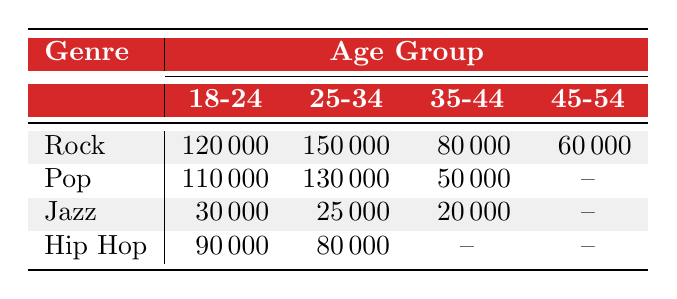What is the attendance for Rock music concerts among the 25-34 age group? The table shows the attendance for different genres among various age groups. For Rock concerts, the attendance for the 25-34 age group is listed as 150000.
Answer: 150000 Which genre has the lowest attendance for the 35-44 age group? By examining the attendances in the 35-44 age group for each genre: Rock has 80000, Pop has 50000, Jazz has 20000, and Hip Hop is not listed (represented by {--}). The lowest attendance is for Jazz with 20000.
Answer: Jazz What is the total attendance for Rock and Pop concerts combined for the 18-24 age group? The attendance for Rock in the 18-24 age group is 120000 and for Pop, it is 110000. Adding these together, 120000 + 110000 equals 230000.
Answer: 230000 Is there any age group for Jazz music concerts that has attendance? Looking at the Jazz attendance, the age groups 18-24, 25-34, and 35-44 have values of 30000, 25000, and 20000 respectively, while 45-54 is not listed (represented by {--}). This means that Jazz has attendance in age groups 18-24, 25-34, and 35-44.
Answer: Yes What is the average attendance for Hip Hop concerts across all age groups reported? In the table for Hip Hop: 18-24 has 90000, 25-34 has 80000, and the other age groups (35-44 and 45-54) show no attendance (represented by {--}). To calculate the average, we will consider only the available attendances: (90000 + 80000) / 2 = 85000. Therefore, the average is calculated based on the two data points we have.
Answer: 85000 Which age group for Pop has the highest attendance? For Pop music, the attendances for age groups are 18-24 with 110000 and 25-34 with 130000. Comparing these values, the highest attendance occurs in the 25-34 age group with 130000.
Answer: 25-34 What is the difference in attendance between the 18-24 age group for Rock and Hip Hop? The attendance for Rock in the 18-24 age group is 120000, while for Hip Hop it is 90000. To find the difference, subtract the Hip Hop attendance from Rock's attendance: 120000 - 90000 equals 30000.
Answer: 30000 Are there any genres that do not have attendance data for the 45-54 age group? In the table, Pop and Hip Hop do not have attendance data listed for 45-54 (represented by {--}), while Rock shows 60000, and Jazz is also not listed. Therefore, both Pop and Hip Hop do not have attendance data for that age group.
Answer: Yes 